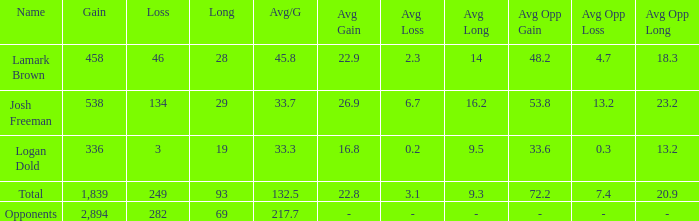Which Avg/G has a Name of josh freeman, and a Loss smaller than 134? None. 